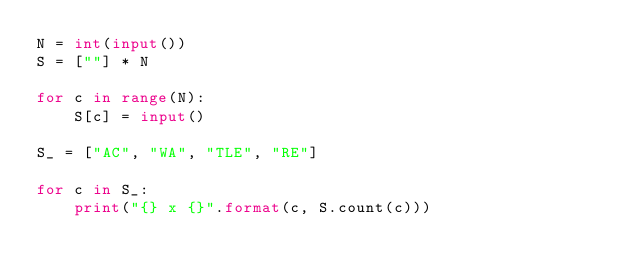Convert code to text. <code><loc_0><loc_0><loc_500><loc_500><_Python_>N = int(input())
S = [""] * N

for c in range(N):
	S[c] = input()

S_ = ["AC", "WA", "TLE", "RE"]

for c in S_:
	print("{} x {}".format(c, S.count(c)))
</code> 